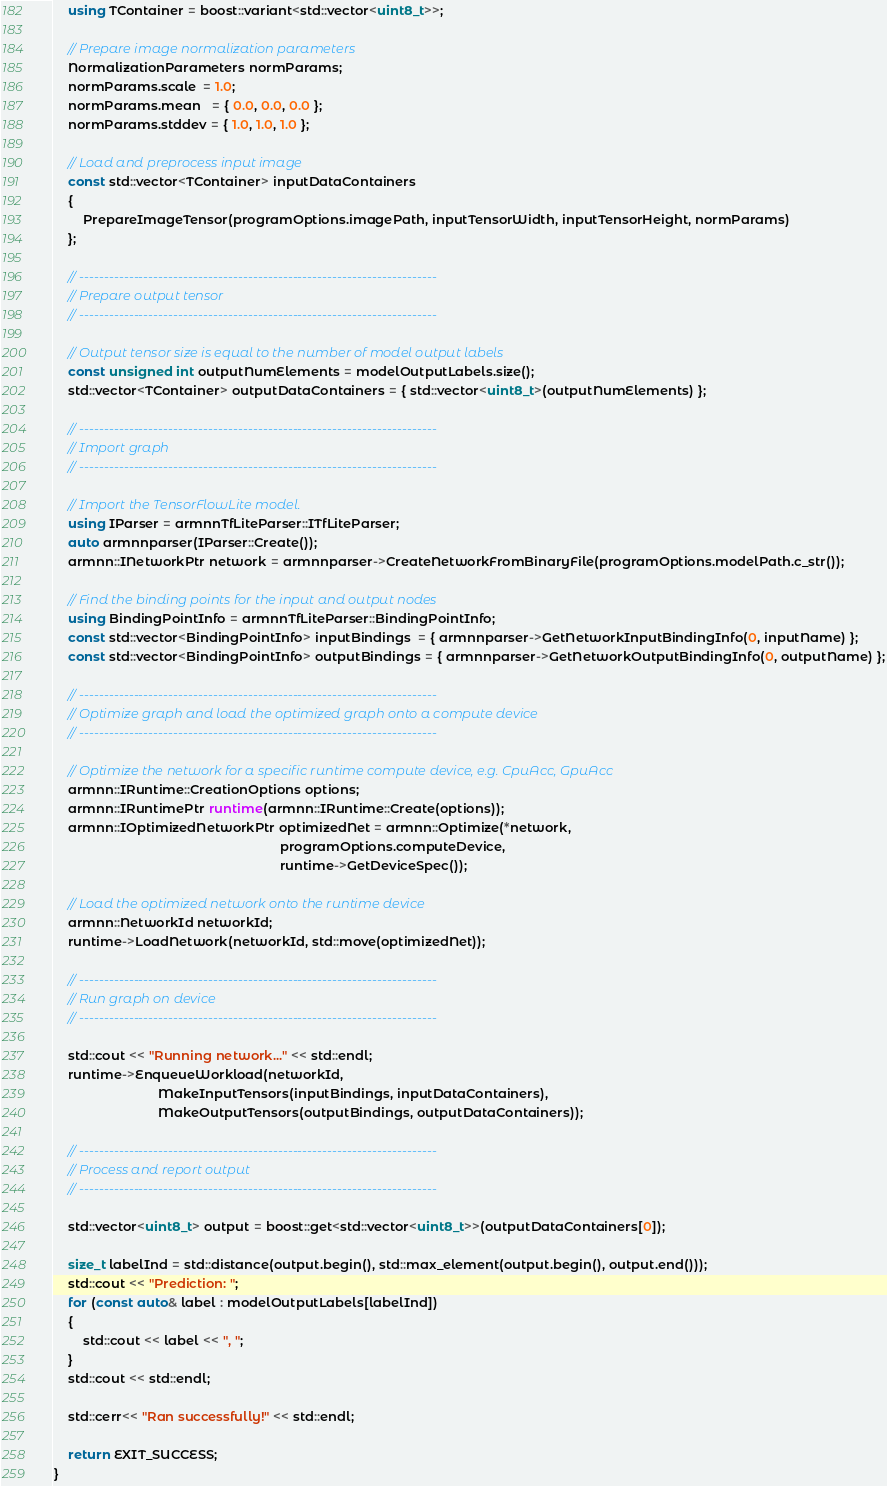Convert code to text. <code><loc_0><loc_0><loc_500><loc_500><_C++_>    using TContainer = boost::variant<std::vector<uint8_t>>;

    // Prepare image normalization parameters
    NormalizationParameters normParams;
    normParams.scale  = 1.0;
    normParams.mean   = { 0.0, 0.0, 0.0 };
    normParams.stddev = { 1.0, 1.0, 1.0 };

    // Load and preprocess input image
    const std::vector<TContainer> inputDataContainers
    {
        PrepareImageTensor(programOptions.imagePath, inputTensorWidth, inputTensorHeight, normParams)
    };

    // ------------------------------------------------------------------------
    // Prepare output tensor
    // ------------------------------------------------------------------------

    // Output tensor size is equal to the number of model output labels
    const unsigned int outputNumElements = modelOutputLabels.size();
    std::vector<TContainer> outputDataContainers = { std::vector<uint8_t>(outputNumElements) };

    // ------------------------------------------------------------------------
    // Import graph
    // ------------------------------------------------------------------------

    // Import the TensorFlowLite model.
    using IParser = armnnTfLiteParser::ITfLiteParser;
    auto armnnparser(IParser::Create());
    armnn::INetworkPtr network = armnnparser->CreateNetworkFromBinaryFile(programOptions.modelPath.c_str());

    // Find the binding points for the input and output nodes
    using BindingPointInfo = armnnTfLiteParser::BindingPointInfo;
    const std::vector<BindingPointInfo> inputBindings  = { armnnparser->GetNetworkInputBindingInfo(0, inputName) };
    const std::vector<BindingPointInfo> outputBindings = { armnnparser->GetNetworkOutputBindingInfo(0, outputName) };

    // ------------------------------------------------------------------------
    // Optimize graph and load the optimized graph onto a compute device
    // ------------------------------------------------------------------------

    // Optimize the network for a specific runtime compute device, e.g. CpuAcc, GpuAcc
    armnn::IRuntime::CreationOptions options;
    armnn::IRuntimePtr runtime(armnn::IRuntime::Create(options));
    armnn::IOptimizedNetworkPtr optimizedNet = armnn::Optimize(*network,
                                                               programOptions.computeDevice,
                                                               runtime->GetDeviceSpec());

    // Load the optimized network onto the runtime device
    armnn::NetworkId networkId;
    runtime->LoadNetwork(networkId, std::move(optimizedNet));

    // ------------------------------------------------------------------------
    // Run graph on device
    // ------------------------------------------------------------------------

    std::cout << "Running network..." << std::endl;
    runtime->EnqueueWorkload(networkId,
                             MakeInputTensors(inputBindings, inputDataContainers),
                             MakeOutputTensors(outputBindings, outputDataContainers));

    // ------------------------------------------------------------------------
    // Process and report output
    // ------------------------------------------------------------------------

    std::vector<uint8_t> output = boost::get<std::vector<uint8_t>>(outputDataContainers[0]);

    size_t labelInd = std::distance(output.begin(), std::max_element(output.begin(), output.end()));
    std::cout << "Prediction: ";
    for (const auto& label : modelOutputLabels[labelInd])
    {
        std::cout << label << ", ";
    }
    std::cout << std::endl;

    std::cerr<< "Ran successfully!" << std::endl;

    return EXIT_SUCCESS;
}
</code> 